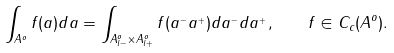Convert formula to latex. <formula><loc_0><loc_0><loc_500><loc_500>\int _ { A ^ { o } } f ( a ) d a = \int _ { A ^ { o } _ { l - } \times A ^ { o } _ { l + } } f ( a ^ { _ { - } } a ^ { _ { + } } ) d a ^ { _ { - } } d a ^ { _ { + } } , \quad f \in C _ { c } ( A ^ { o } ) .</formula> 